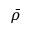Convert formula to latex. <formula><loc_0><loc_0><loc_500><loc_500>\bar { \rho }</formula> 